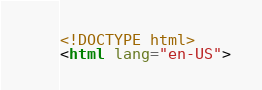<code> <loc_0><loc_0><loc_500><loc_500><_HTML_>
<!DOCTYPE html>
<html lang="en-US">
</code> 